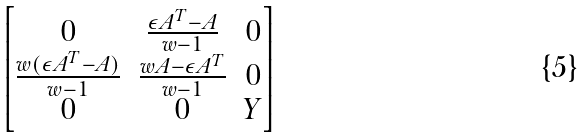<formula> <loc_0><loc_0><loc_500><loc_500>\begin{bmatrix} 0 & \frac { \epsilon A ^ { T } - A } { w - 1 } & 0 \\ \frac { w ( \epsilon A ^ { T } - A ) } { w - 1 } & \frac { w A - \epsilon A ^ { T } } { w - 1 } & 0 \\ 0 & 0 & Y \end{bmatrix}</formula> 